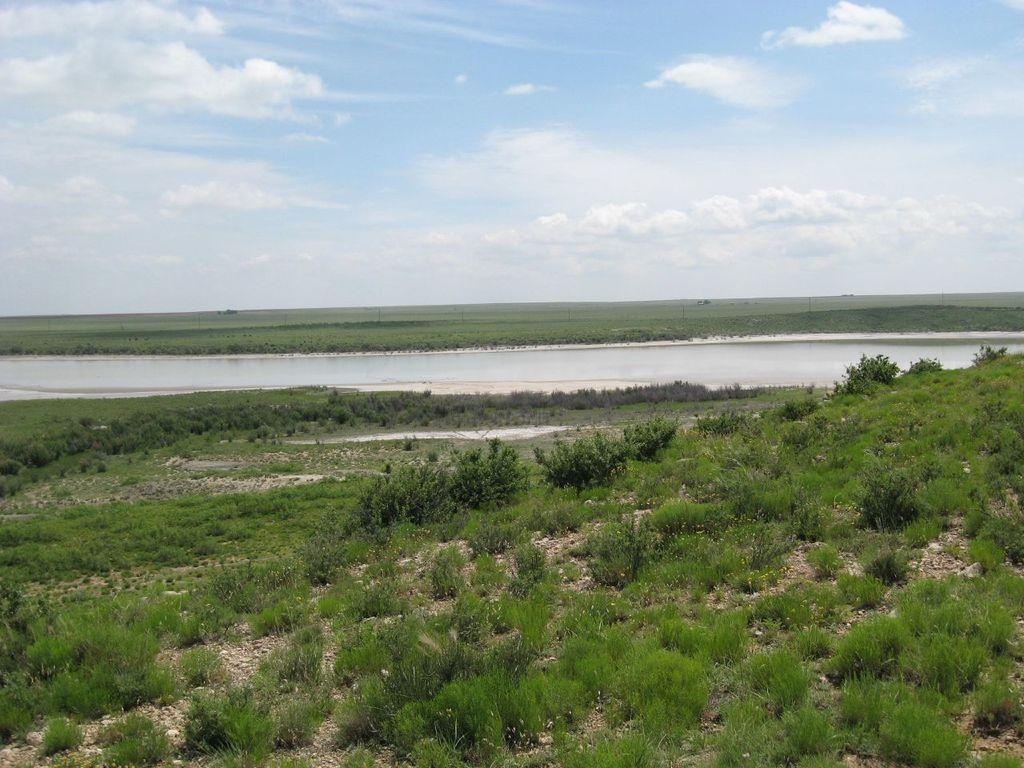What type of vegetation can be seen in the image? There are trees in the image. What color are the trees? The trees are green in color. What can be seen in the background of the image? There is water visible in the background of the image. What colors are present in the sky in the image? The sky is blue and white in color. How many pages are visible in the image? There are no pages present in the image; it features trees, water, and a blue and white sky. 